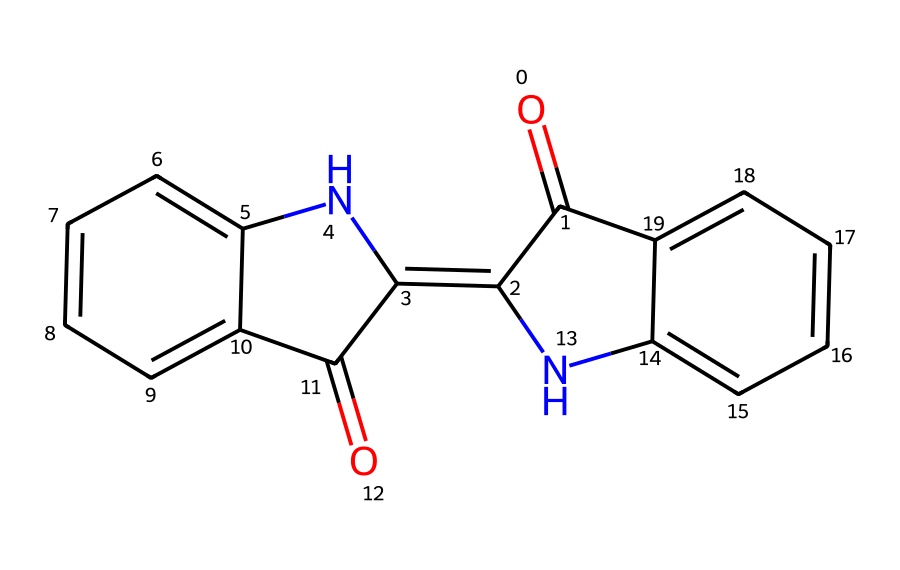What is the main functional group present in indigo? The indigo molecule features a carbonyl group (C=O) which is characteristic of its structure. The carbonyl is found twice in the overall structure, indicating that this functional group is significant.
Answer: carbonyl How many aromatic rings does indigo have? By analyzing the chemical structure, two distinct aromatic rings can be identified in the molecule. The presence of these rings confirms the aromatic nature of indigo.
Answer: two What is the molecular formula of indigo? Counting the atoms present in the SMILES representation, there are 16 carbons, 10 hydrogens, 2 nitrogens, and 2 oxygens, combining this gives the molecular formula C16H10N2O2.
Answer: C16H10N2O2 Which part of indigo contributes primarily to its color? The conjugated system of double bonds in the aromatic rings interacts with light to absorb specific wavelengths, primarily contributing to the dye's characteristic blue color.
Answer: conjugated system Does indigo exhibit any symmetry in its structure? Analyzing the arrangement of atoms in the structure, the molecule has a plane of symmetry, making it symmetric and affecting its optical properties.
Answer: symmetric 